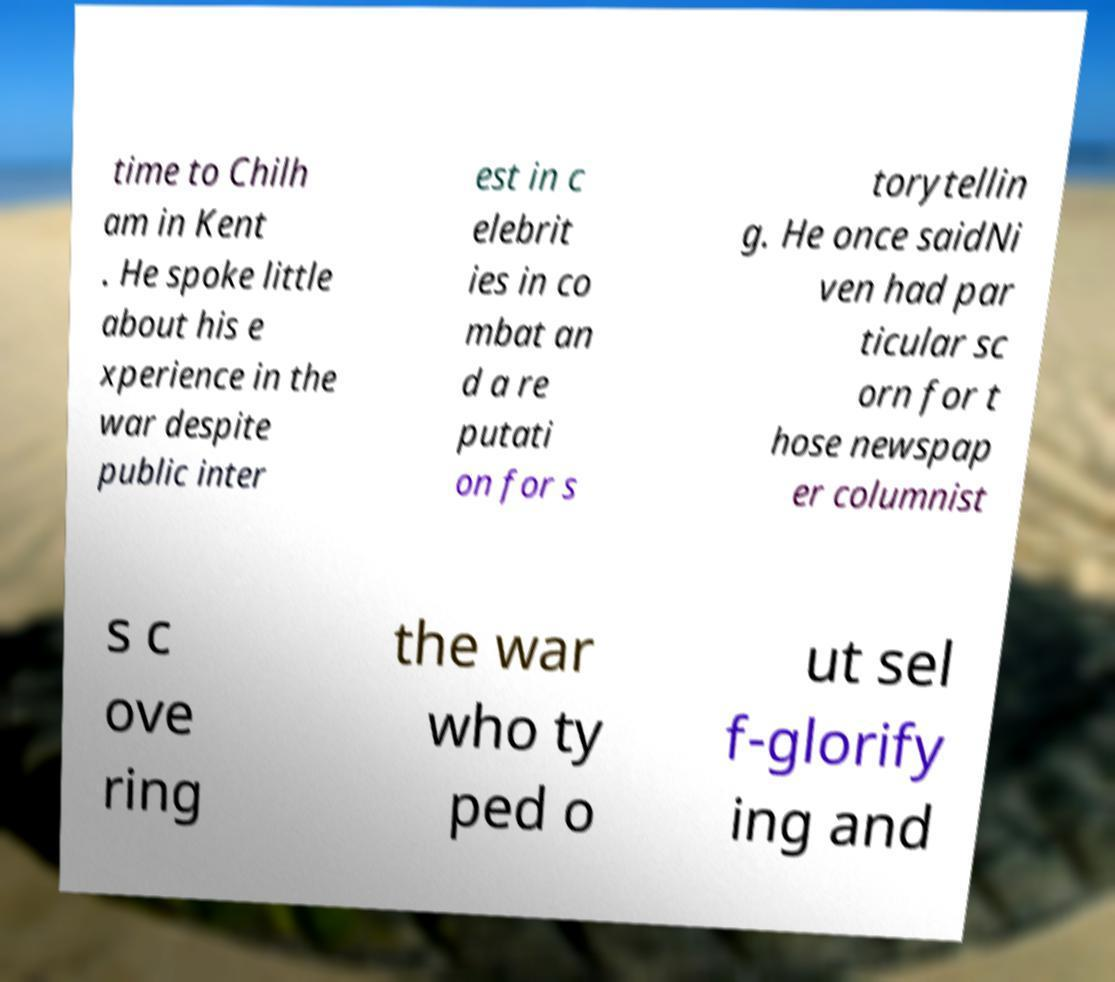Can you accurately transcribe the text from the provided image for me? time to Chilh am in Kent . He spoke little about his e xperience in the war despite public inter est in c elebrit ies in co mbat an d a re putati on for s torytellin g. He once saidNi ven had par ticular sc orn for t hose newspap er columnist s c ove ring the war who ty ped o ut sel f-glorify ing and 